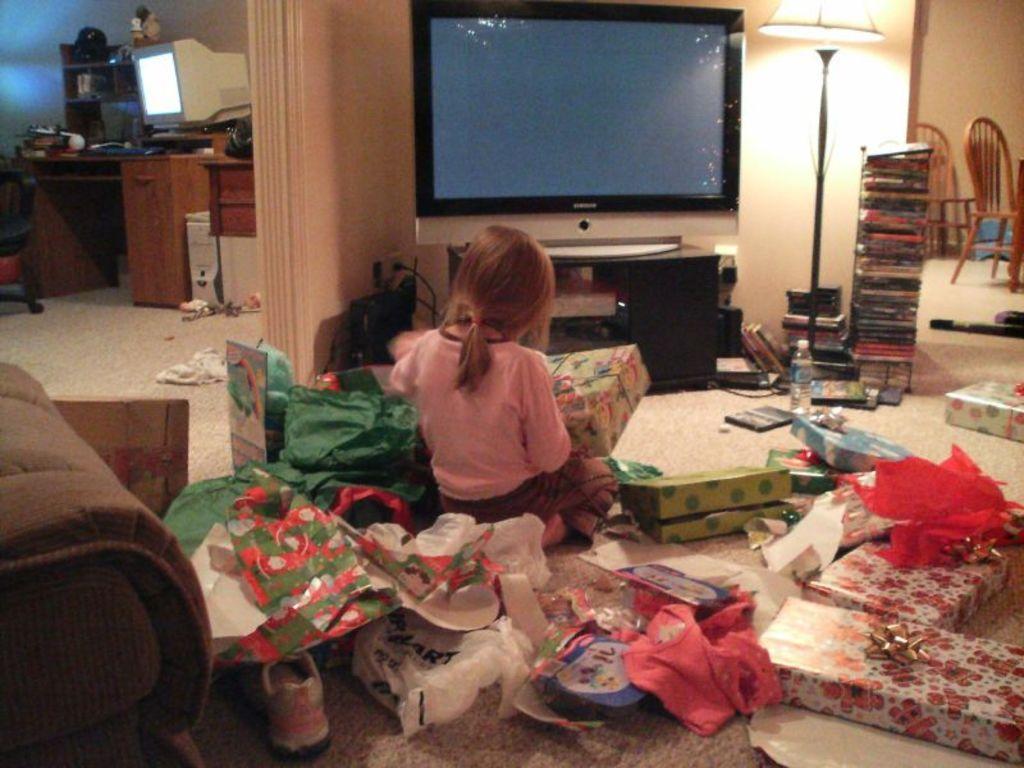Describe this image in one or two sentences. The image is inside the room, In the image there is a girl sitting on floor and holding a gift pack. On right side there is a chair,wall and some books,lamp. On left side we can see computer,keyboard on table and a shelf with some toys. In middle there is a television on floor we can see shoes,water bottle,gifts packs and a mat. 